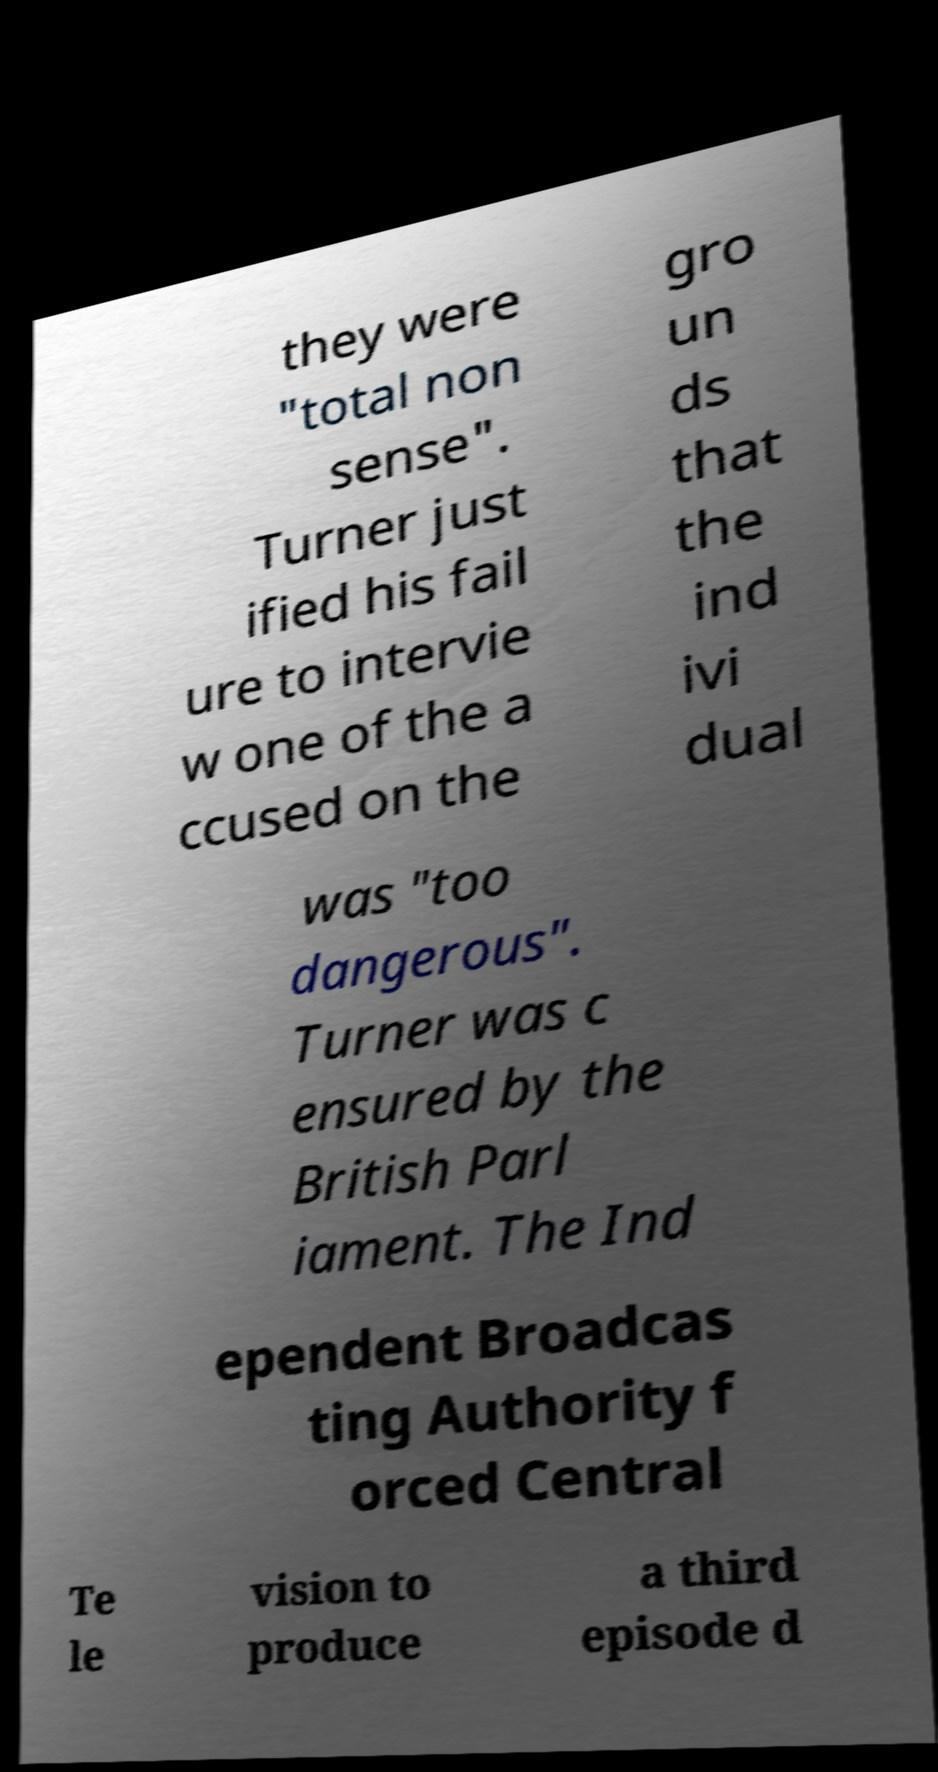There's text embedded in this image that I need extracted. Can you transcribe it verbatim? they were "total non sense". Turner just ified his fail ure to intervie w one of the a ccused on the gro un ds that the ind ivi dual was "too dangerous". Turner was c ensured by the British Parl iament. The Ind ependent Broadcas ting Authority f orced Central Te le vision to produce a third episode d 